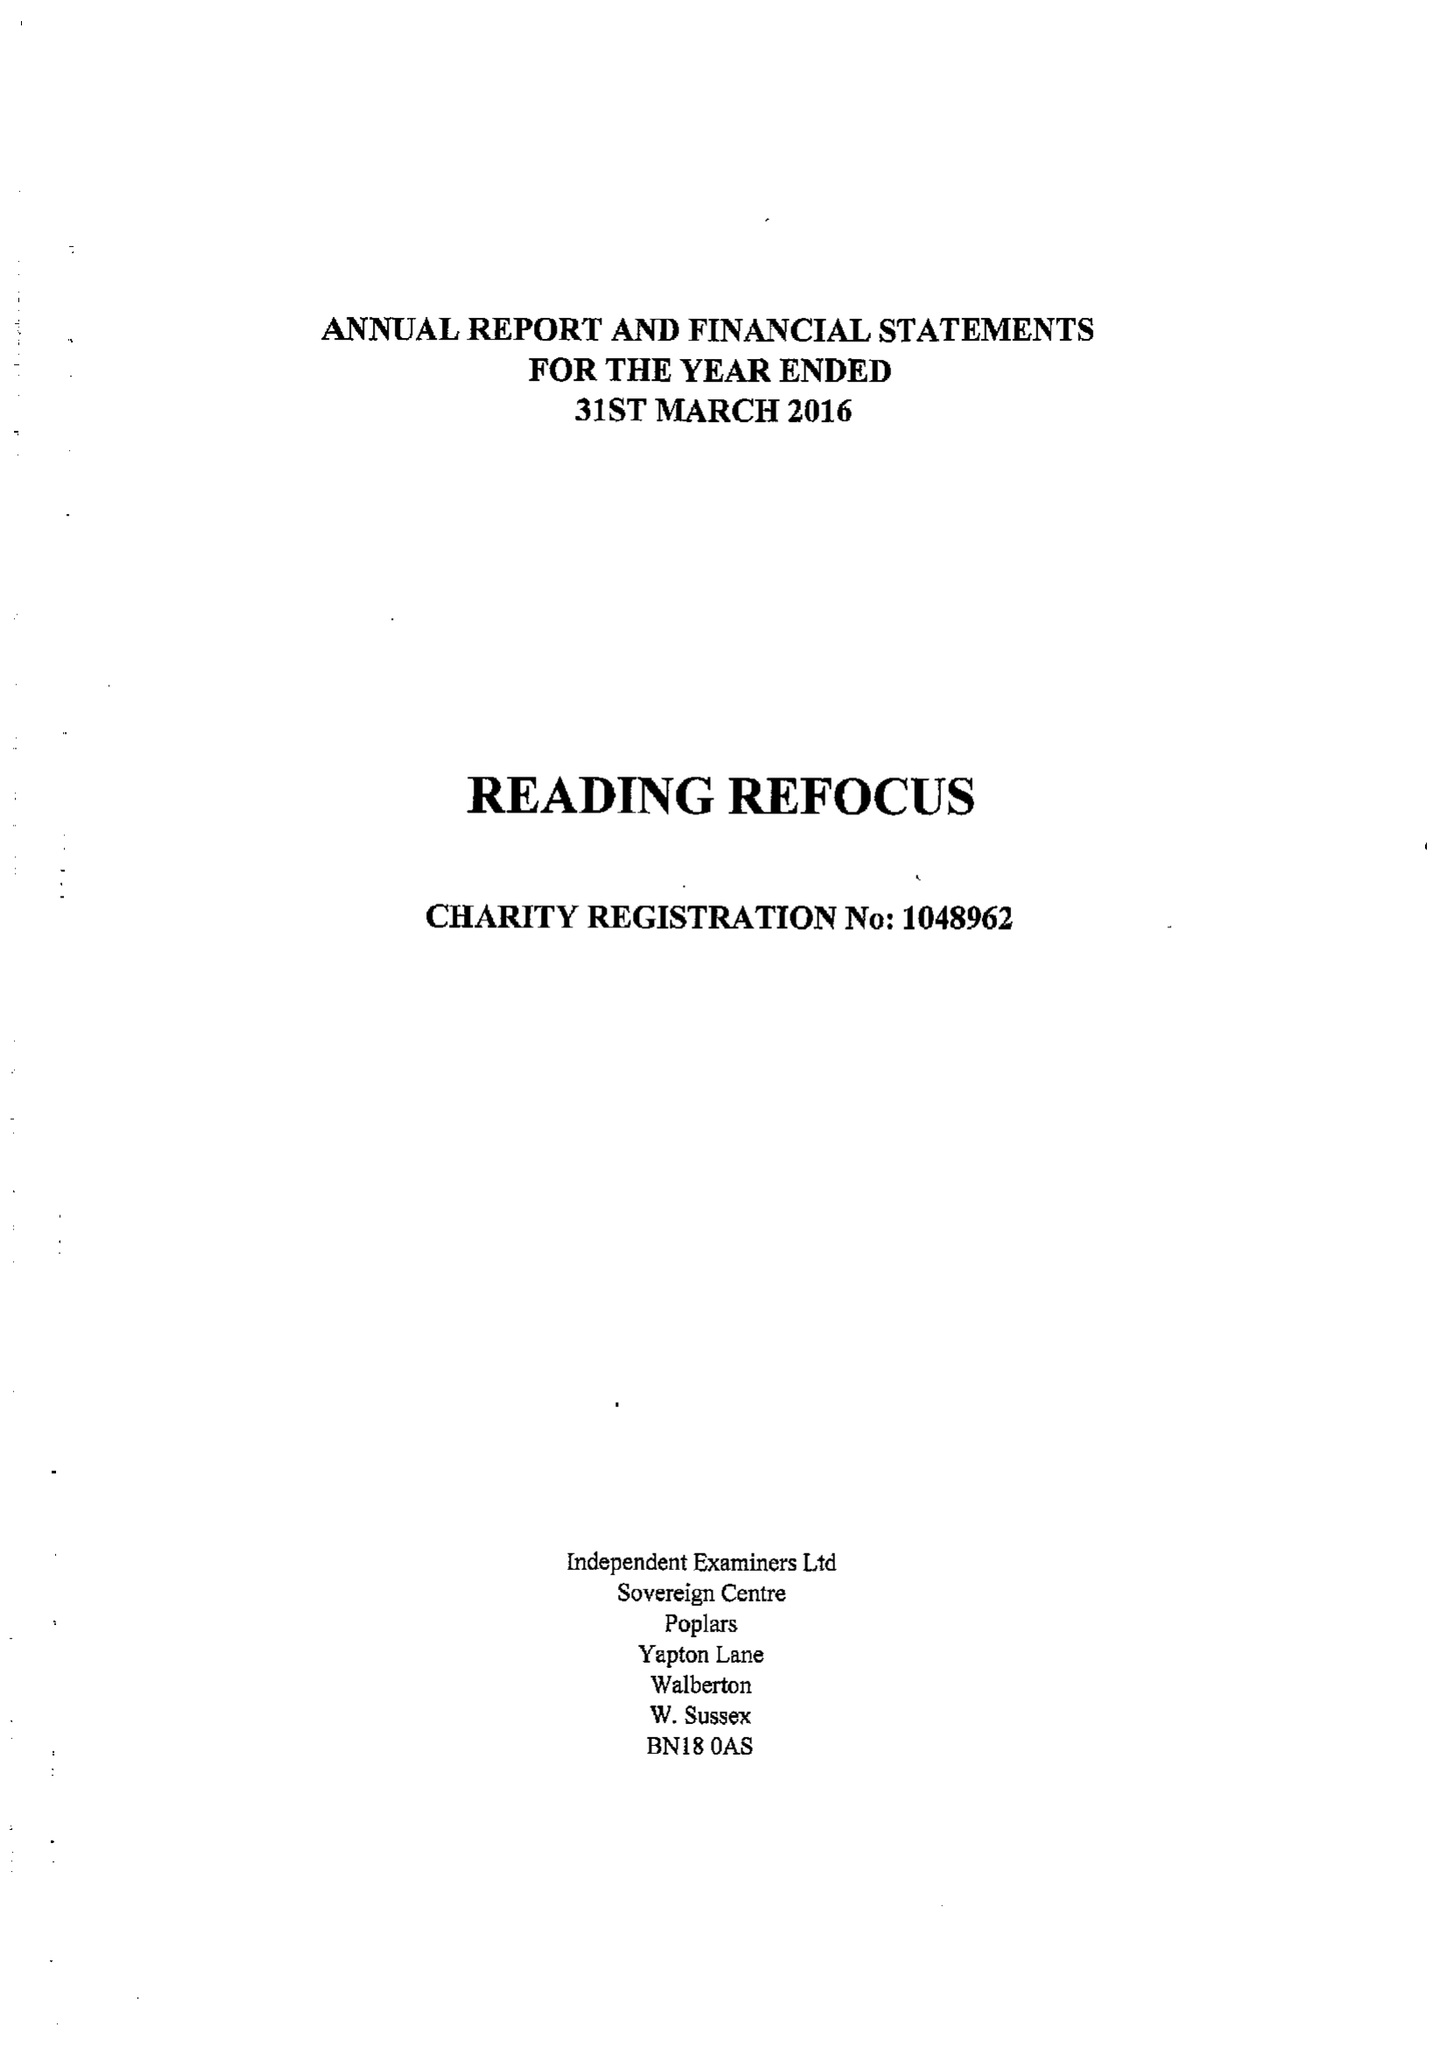What is the value for the address__street_line?
Answer the question using a single word or phrase. 21 SOUTH STREET 